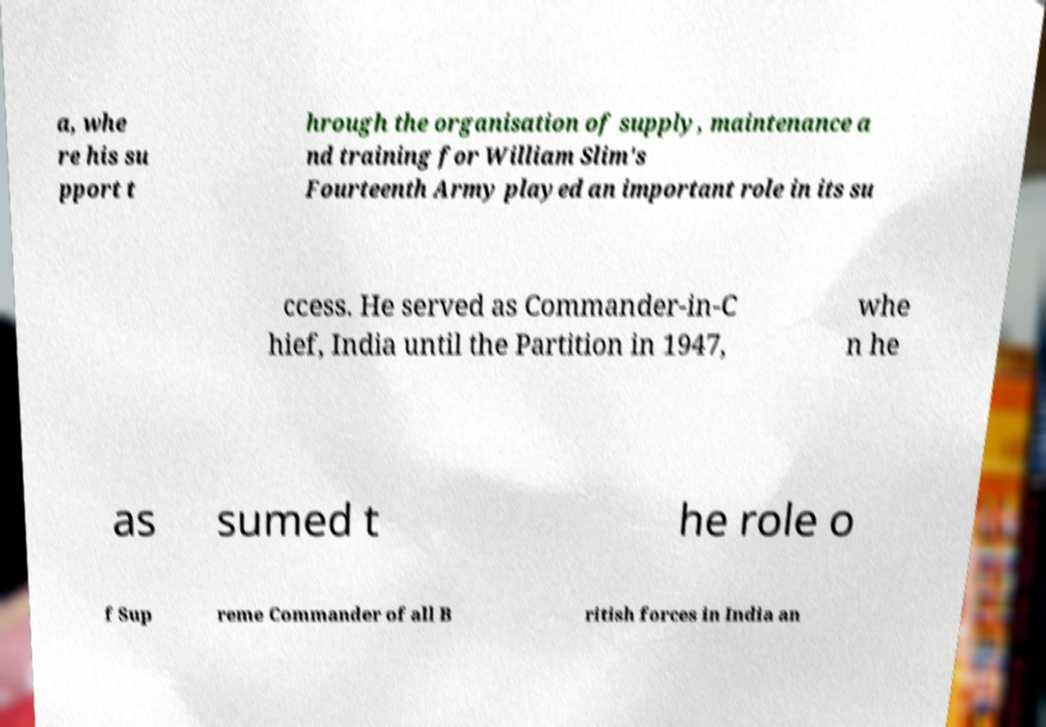Can you accurately transcribe the text from the provided image for me? a, whe re his su pport t hrough the organisation of supply, maintenance a nd training for William Slim's Fourteenth Army played an important role in its su ccess. He served as Commander-in-C hief, India until the Partition in 1947, whe n he as sumed t he role o f Sup reme Commander of all B ritish forces in India an 